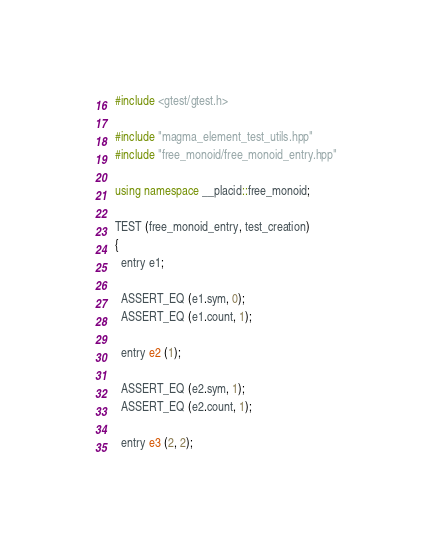Convert code to text. <code><loc_0><loc_0><loc_500><loc_500><_C++_>#include <gtest/gtest.h>

#include "magma_element_test_utils.hpp"
#include "free_monoid/free_monoid_entry.hpp"

using namespace __placid::free_monoid;

TEST (free_monoid_entry, test_creation)
{
  entry e1;

  ASSERT_EQ (e1.sym, 0);
  ASSERT_EQ (e1.count, 1);

  entry e2 (1);

  ASSERT_EQ (e2.sym, 1);
  ASSERT_EQ (e2.count, 1);

  entry e3 (2, 2);
</code> 